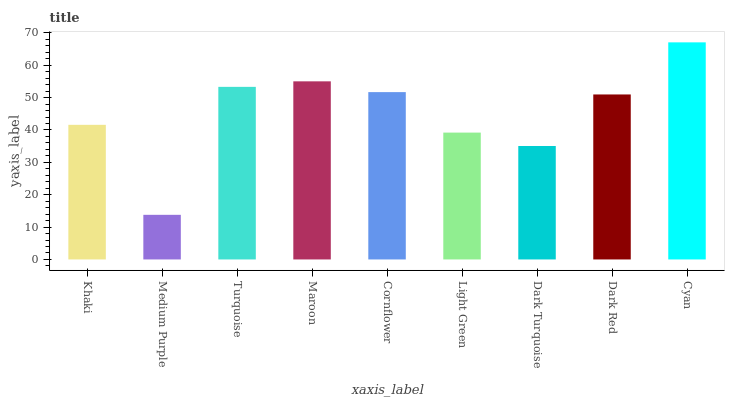Is Medium Purple the minimum?
Answer yes or no. Yes. Is Cyan the maximum?
Answer yes or no. Yes. Is Turquoise the minimum?
Answer yes or no. No. Is Turquoise the maximum?
Answer yes or no. No. Is Turquoise greater than Medium Purple?
Answer yes or no. Yes. Is Medium Purple less than Turquoise?
Answer yes or no. Yes. Is Medium Purple greater than Turquoise?
Answer yes or no. No. Is Turquoise less than Medium Purple?
Answer yes or no. No. Is Dark Red the high median?
Answer yes or no. Yes. Is Dark Red the low median?
Answer yes or no. Yes. Is Maroon the high median?
Answer yes or no. No. Is Medium Purple the low median?
Answer yes or no. No. 